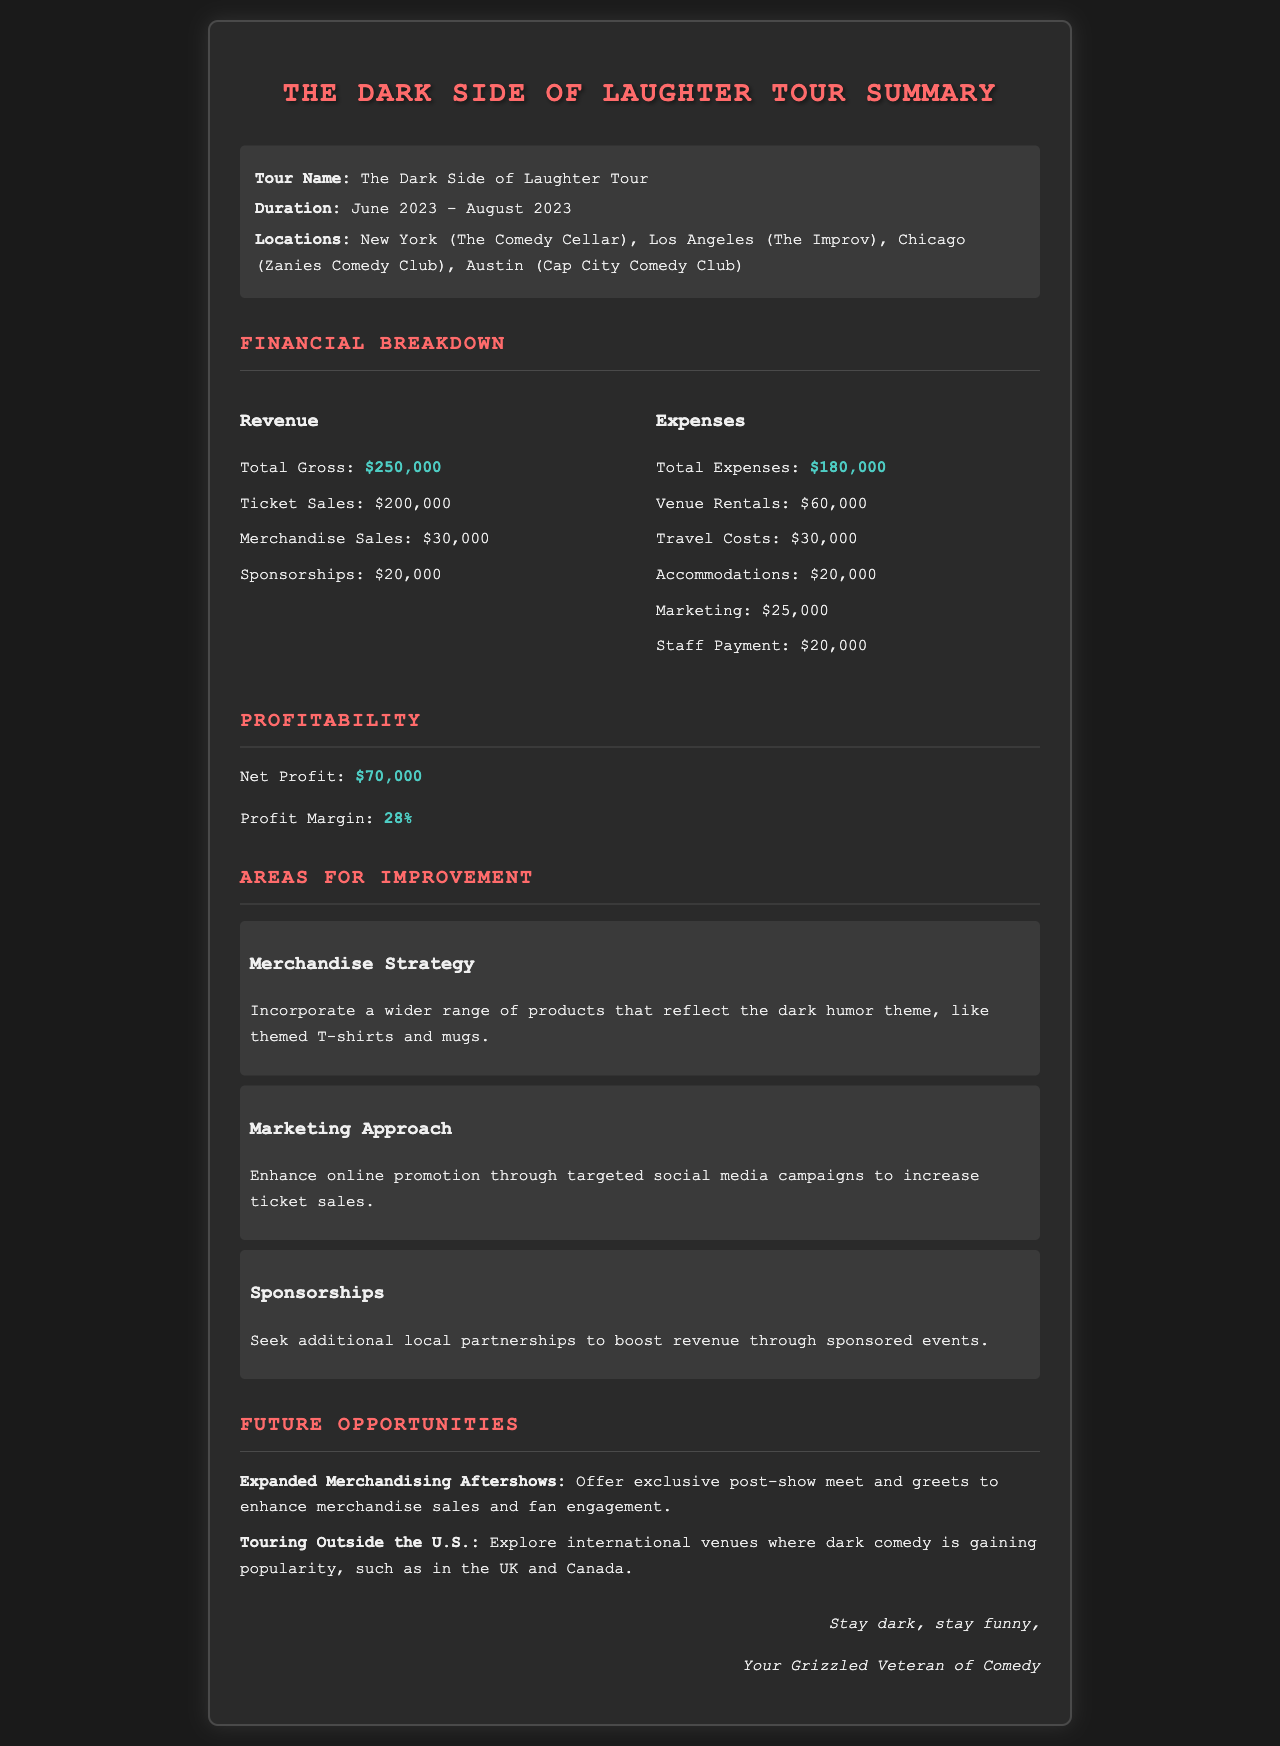What is the total gross revenue? The total gross revenue is stated in the document as $250,000.
Answer: $250,000 What were the total expenses? Total expenses are detailed in the document as $180,000.
Answer: $180,000 What is the profit margin? The profit margin is calculated and mentioned as 28%.
Answer: 28% Which city did the tour stop in first? The first city mentioned in the tour locations is New York.
Answer: New York What is one area for improvement mentioned in the document? Areas for improvement include Merchandise Strategy, which advises expanding the range of products.
Answer: Merchandise Strategy How much was spent on travel costs? The expense on travel costs is listed as $30,000.
Answer: $30,000 What is the net profit from the tour? The document states the net profit is $70,000.
Answer: $70,000 Which sponsorship amount is noted in the revenue breakdown? The sponsorship amount listed in the revenue breakdown is $20,000.
Answer: $20,000 What is suggested to enhance merchandise sales? The suggestion for enhancing merchandise sales is to offer exclusive post-show meet and greets.
Answer: Post-show meet and greets 